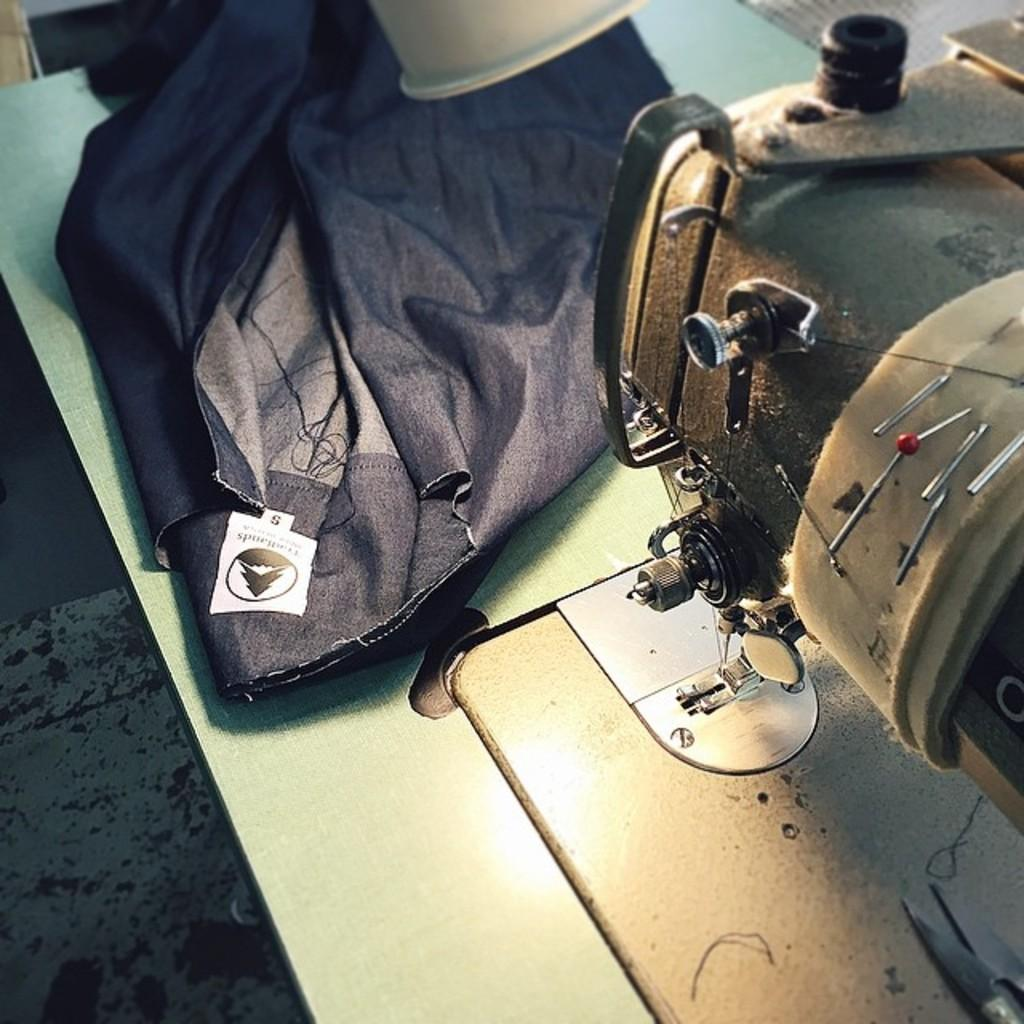What is the main object in the image? There is a sewing machine in the image. What colors are the sewing machine? The sewing machine is black and cream in color. What is the sewing machine placed on? The sewing machine is on a white colored board. What else can be seen on the board? There is a black colored cloth on the board. How much sugar is on the sewing machine in the image? There is no sugar present on the sewing machine in the image. What type of sock is being sewn on the sewing machine in the image? There is no sock present on the sewing machine in the image. 